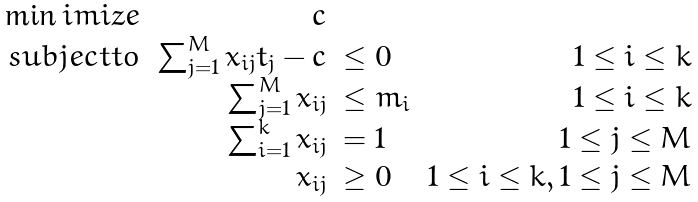<formula> <loc_0><loc_0><loc_500><loc_500>\begin{array} { r r l r } \min i m i z e & c & & \\ s u b j e c t t o & \sum _ { j = 1 } ^ { M } { x _ { i j } t _ { j } } - c & \leq 0 & 1 \leq i \leq k \\ & \sum _ { j = 1 } ^ { M } { x _ { i j } } & \leq m _ { i } & 1 \leq i \leq k \\ & \sum _ { i = 1 } ^ { k } { x _ { i j } } & = 1 & 1 \leq j \leq M \\ & x _ { i j } & \geq 0 & 1 \leq i \leq k , 1 \leq j \leq M \\ \end{array}</formula> 